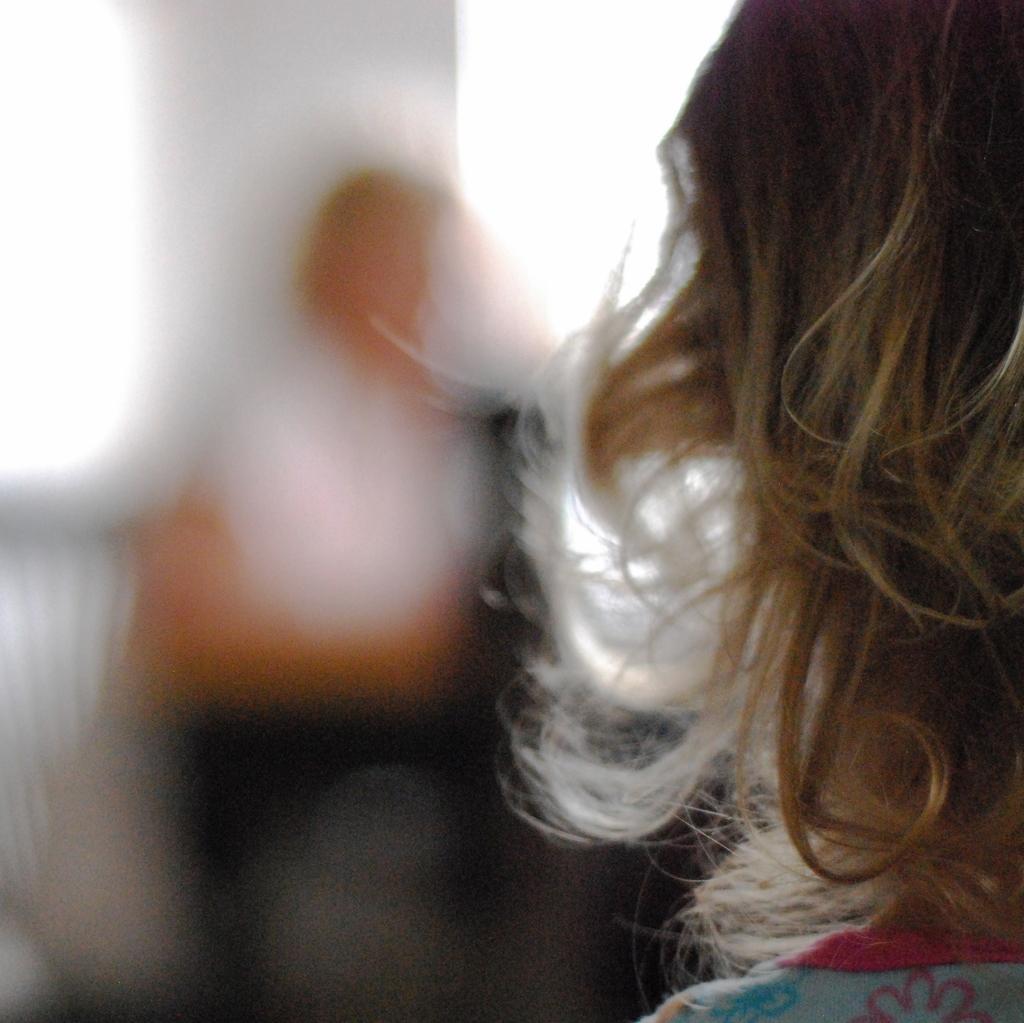Could you give a brief overview of what you see in this image? On the right side, there is a person in front of a person who is sitting, near a wall. 